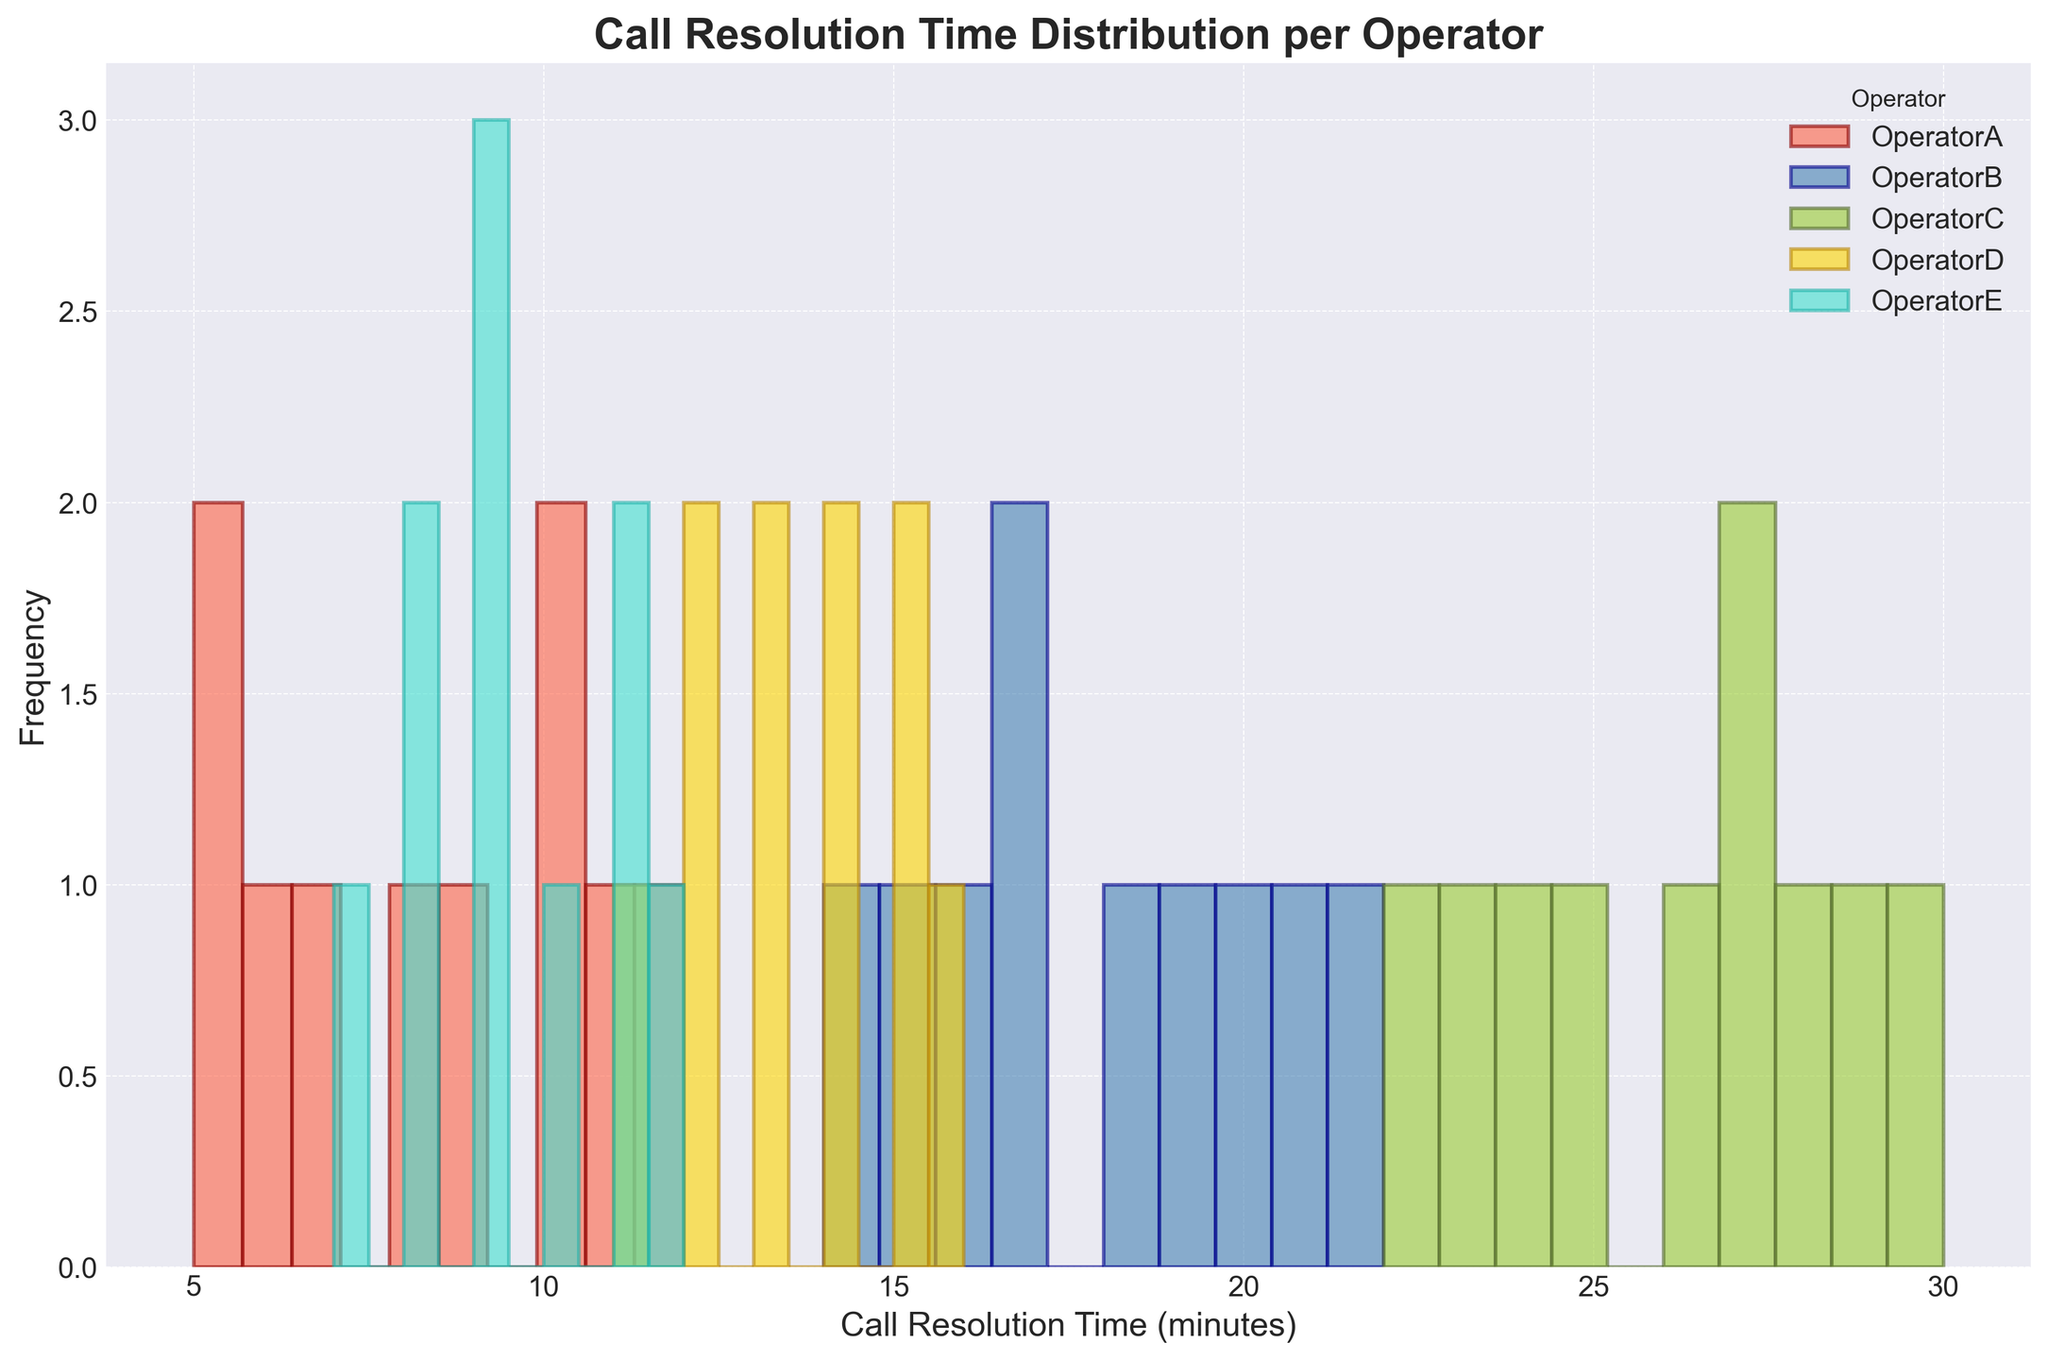How does the range of call resolution times compare between Operator A and Operator B? The range of call resolution times for Operator A is from 5 to 12, giving a range of 7. For Operator B, the range is from 14 to 22, giving a range of 8. Therefore, the range is almost the same, with Operator B having a slightly larger range by 1 minute.
Answer: Very similar, with Operator B slightly larger What is the total frequency of calls with a resolution time of exactly 10 minutes? By looking at the histogram, you can add up the frequencies for each operator at the 10-minute mark. Operator A and Operator E both have calls resolved in 10 minutes. The frequencies for these operators add up to the total.
Answer: Sum of frequencies equal to the total frequency Which operator has the most concentrated distribution of call resolution times? Operator D has the most concentrated call resolution times, mostly centered around 11-16 minutes, indicated by the higher peaks in a narrower range compared to other operators.
Answer: Operator D Between Operator C and Operator E, who has a higher variance in call resolution times? By comparing the spread of the histograms, Operator C has a much wider spread in call resolution times (range includes 22 to 30 minutes) compared to the more concentrated spread for Operator E (range from 7 to 12 minutes). This indicates a higher variance for Operator C.
Answer: Operator C Which operator resolves calls the quickest on average? By observing the general centroids of the histogram bars, it's apparent that Operator A has the lowest call resolution time on average, with most calls resolved between 5 and 12 minutes.
Answer: Operator A Between Operators A and D, whose call resolution frequency has a higher peak? By looking at the histogram, Operator D has a higher peak frequency of around 3-4 calls, whereas Operator A's peak is around 2-3 calls. Therefore, Operator D has a higher peak frequency.
Answer: Operator D What is the approximate median call resolution time for Operator E? The histogram of Operator E shows that most calls are between 7 and 12 minutes. The median would roughly be in the middle of this range, approximately around 9-10 minutes.
Answer: 9-10 minutes Do any operators share a common call resolution time range? You can see that Operators A and E share a common call resolution time range around the 8-12 minute mark as their histograms overlap in this range.
Answer: Yes, Operators A and E For Operator B, is the highest frequency of call resolution times closer to the lower or higher end of their distribution? Operator B's histogram shows the highest peak around the middle to higher end of the distribution, particularly around 16-18 minutes.
Answer: Closer to the higher end 